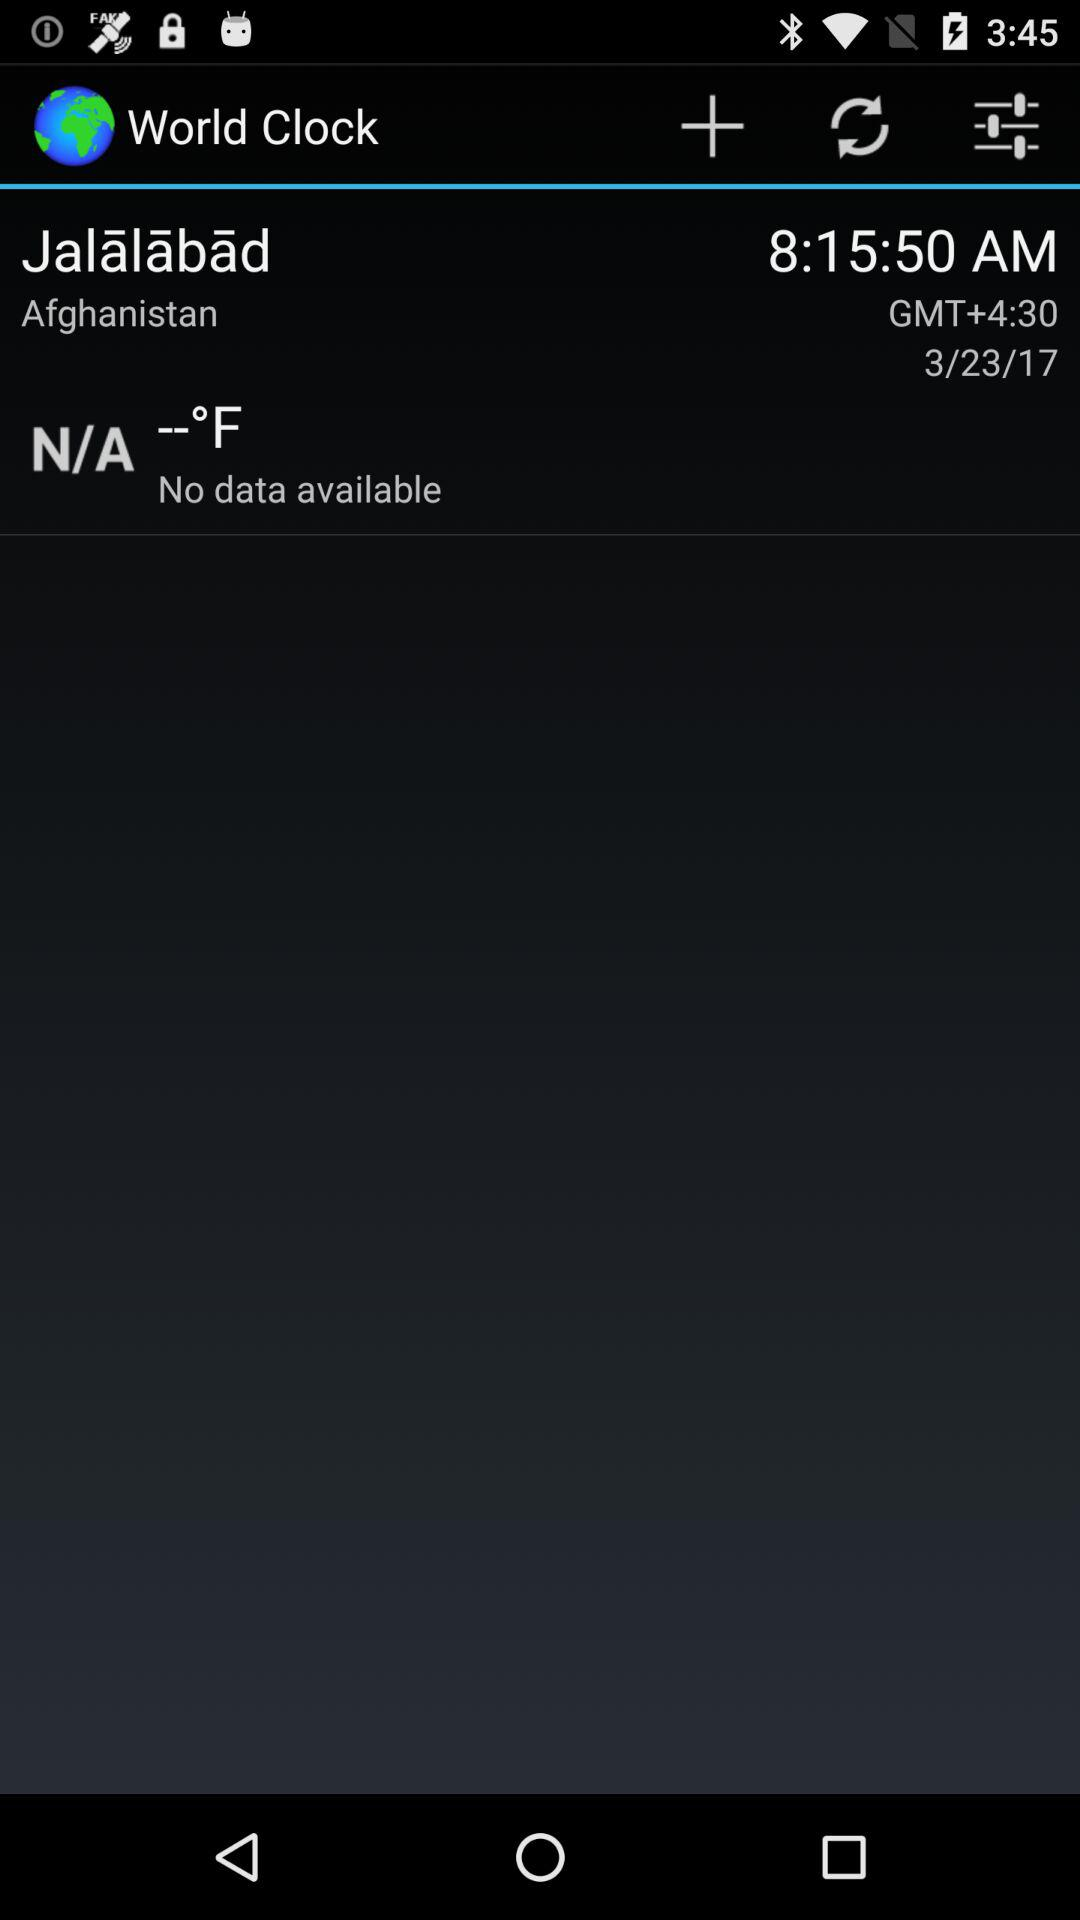What is the app's title? The app's title is "World Clock". 